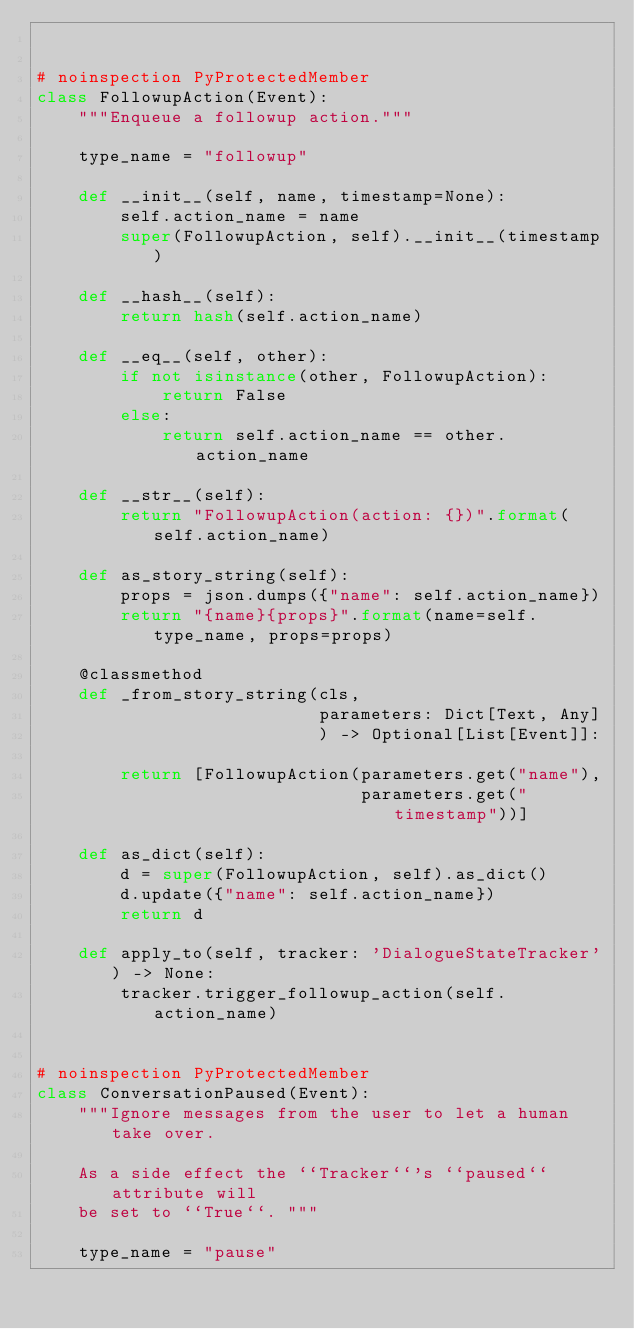Convert code to text. <code><loc_0><loc_0><loc_500><loc_500><_Python_>

# noinspection PyProtectedMember
class FollowupAction(Event):
    """Enqueue a followup action."""

    type_name = "followup"

    def __init__(self, name, timestamp=None):
        self.action_name = name
        super(FollowupAction, self).__init__(timestamp)

    def __hash__(self):
        return hash(self.action_name)

    def __eq__(self, other):
        if not isinstance(other, FollowupAction):
            return False
        else:
            return self.action_name == other.action_name

    def __str__(self):
        return "FollowupAction(action: {})".format(self.action_name)

    def as_story_string(self):
        props = json.dumps({"name": self.action_name})
        return "{name}{props}".format(name=self.type_name, props=props)

    @classmethod
    def _from_story_string(cls,
                           parameters: Dict[Text, Any]
                           ) -> Optional[List[Event]]:

        return [FollowupAction(parameters.get("name"),
                               parameters.get("timestamp"))]

    def as_dict(self):
        d = super(FollowupAction, self).as_dict()
        d.update({"name": self.action_name})
        return d

    def apply_to(self, tracker: 'DialogueStateTracker') -> None:
        tracker.trigger_followup_action(self.action_name)


# noinspection PyProtectedMember
class ConversationPaused(Event):
    """Ignore messages from the user to let a human take over.

    As a side effect the ``Tracker``'s ``paused`` attribute will
    be set to ``True``. """

    type_name = "pause"
</code> 